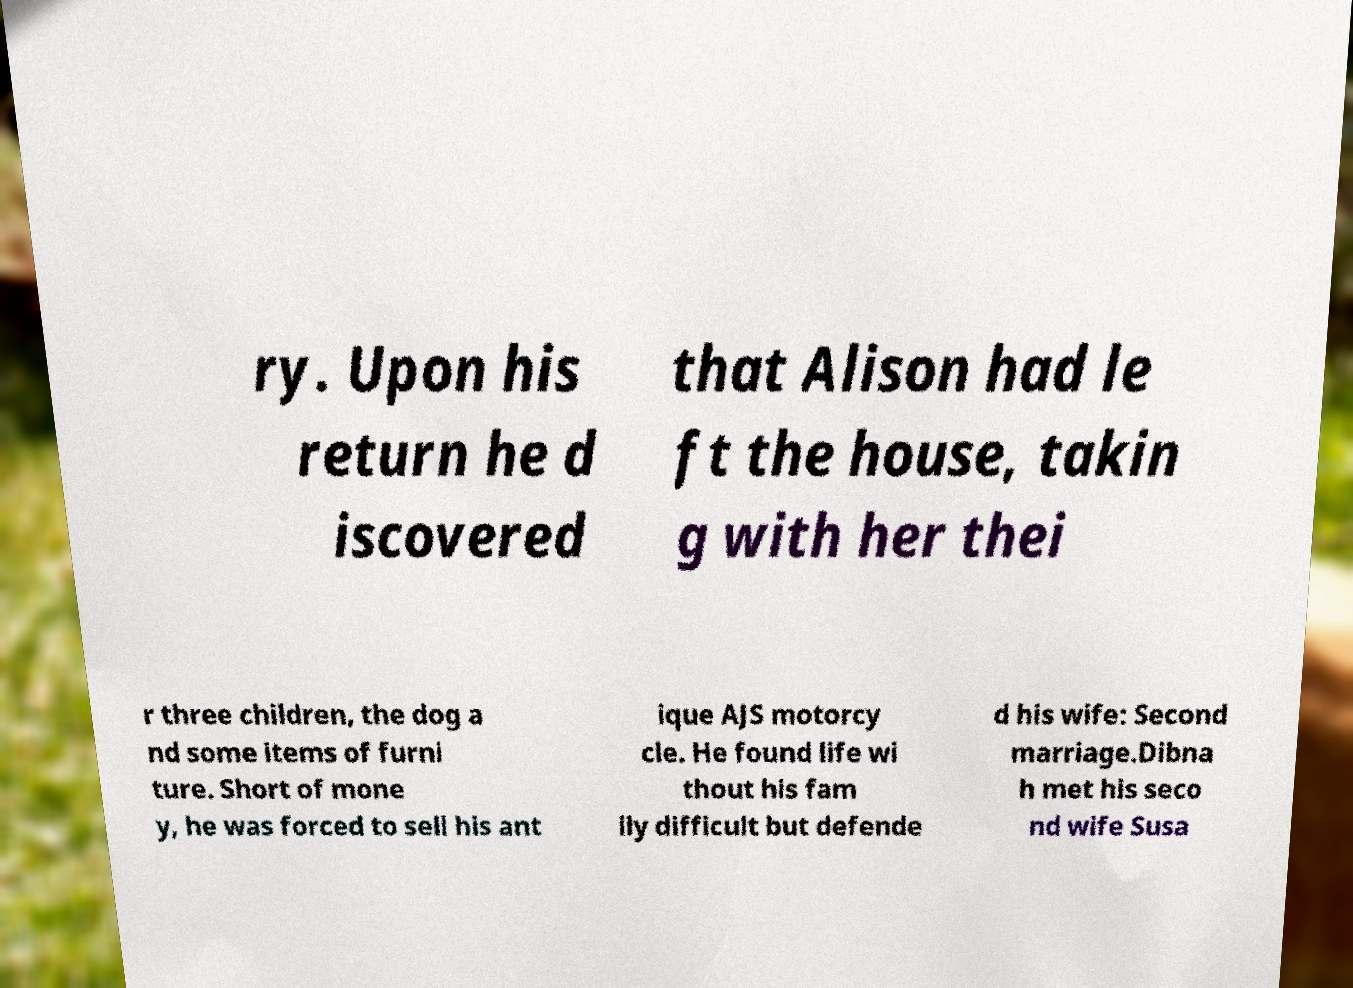There's text embedded in this image that I need extracted. Can you transcribe it verbatim? ry. Upon his return he d iscovered that Alison had le ft the house, takin g with her thei r three children, the dog a nd some items of furni ture. Short of mone y, he was forced to sell his ant ique AJS motorcy cle. He found life wi thout his fam ily difficult but defende d his wife: Second marriage.Dibna h met his seco nd wife Susa 